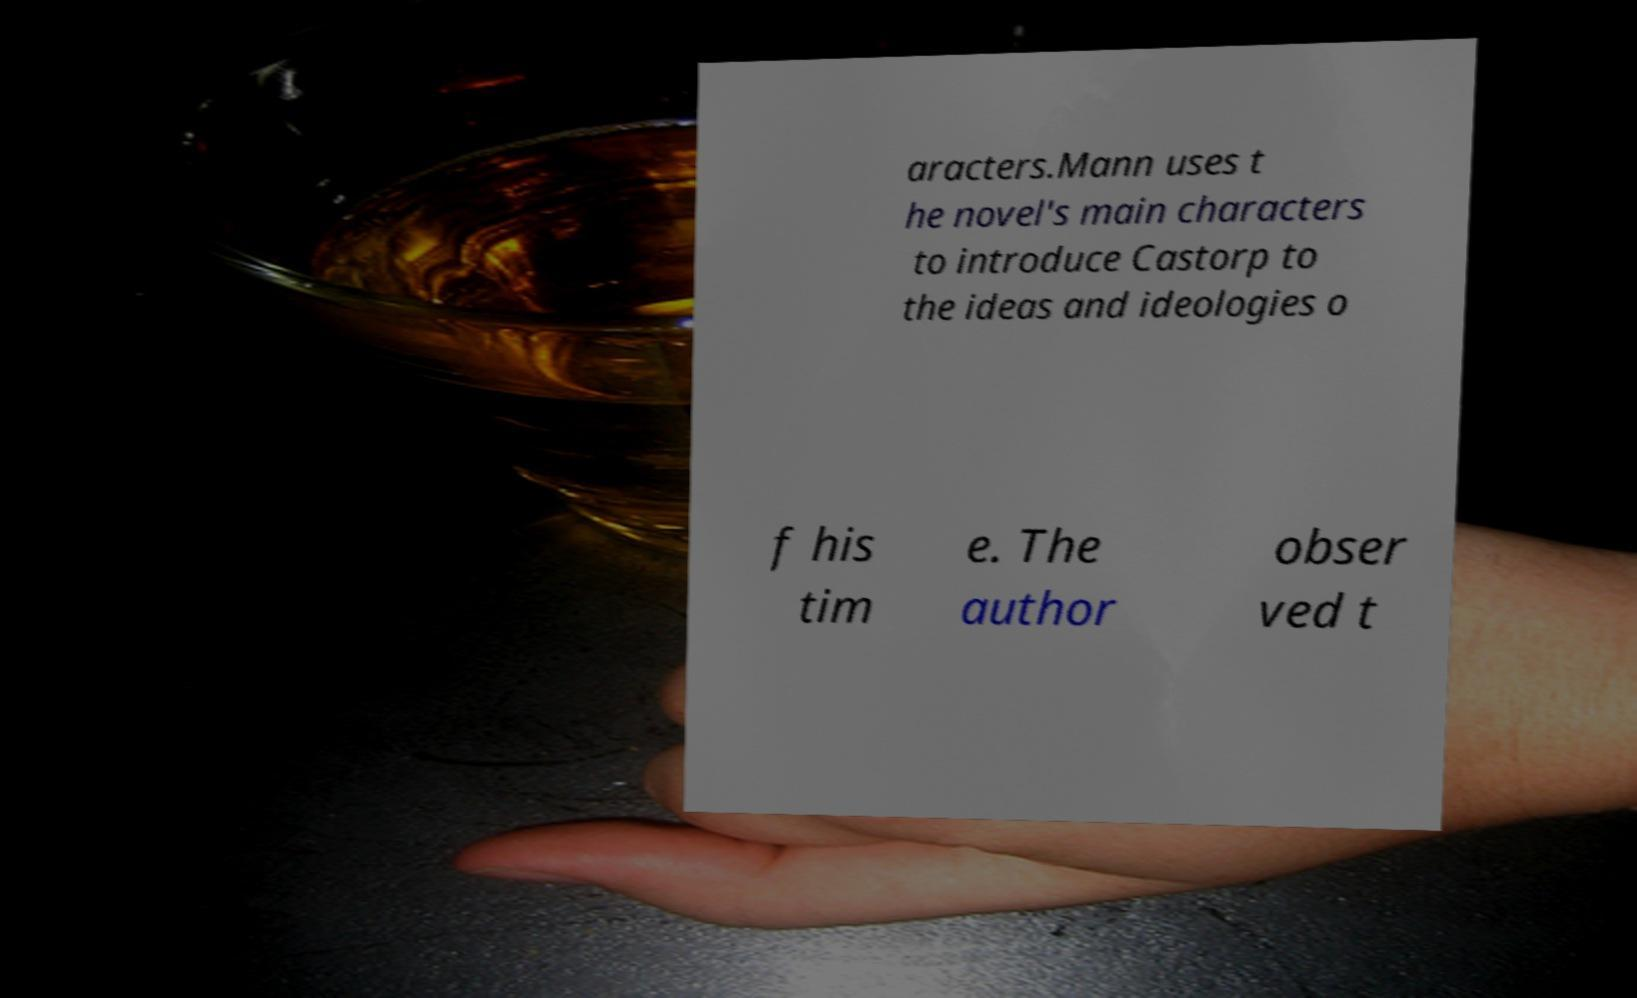Please identify and transcribe the text found in this image. aracters.Mann uses t he novel's main characters to introduce Castorp to the ideas and ideologies o f his tim e. The author obser ved t 